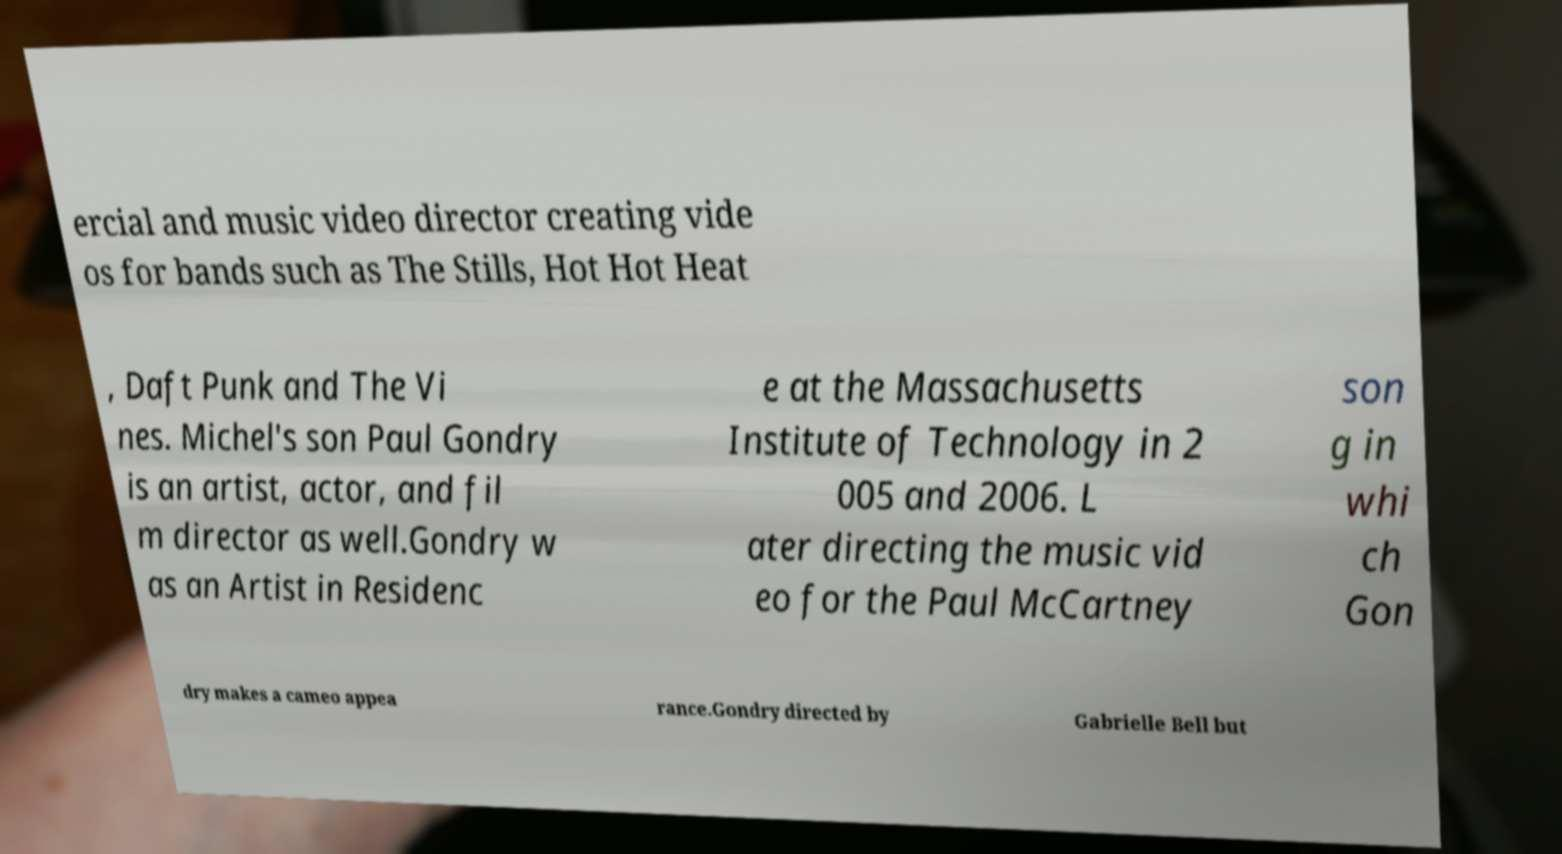There's text embedded in this image that I need extracted. Can you transcribe it verbatim? ercial and music video director creating vide os for bands such as The Stills, Hot Hot Heat , Daft Punk and The Vi nes. Michel's son Paul Gondry is an artist, actor, and fil m director as well.Gondry w as an Artist in Residenc e at the Massachusetts Institute of Technology in 2 005 and 2006. L ater directing the music vid eo for the Paul McCartney son g in whi ch Gon dry makes a cameo appea rance.Gondry directed by Gabrielle Bell but 